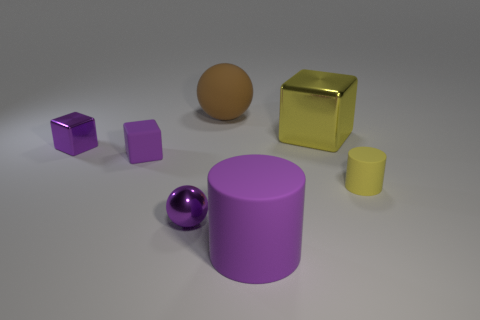Add 2 brown things. How many objects exist? 9 Subtract all rubber cubes. How many cubes are left? 2 Subtract all gray balls. How many purple cubes are left? 2 Subtract 0 red spheres. How many objects are left? 7 Subtract all cubes. How many objects are left? 4 Subtract 2 cubes. How many cubes are left? 1 Subtract all gray cylinders. Subtract all purple balls. How many cylinders are left? 2 Subtract all large yellow objects. Subtract all yellow blocks. How many objects are left? 5 Add 4 blocks. How many blocks are left? 7 Add 4 big brown matte objects. How many big brown matte objects exist? 5 